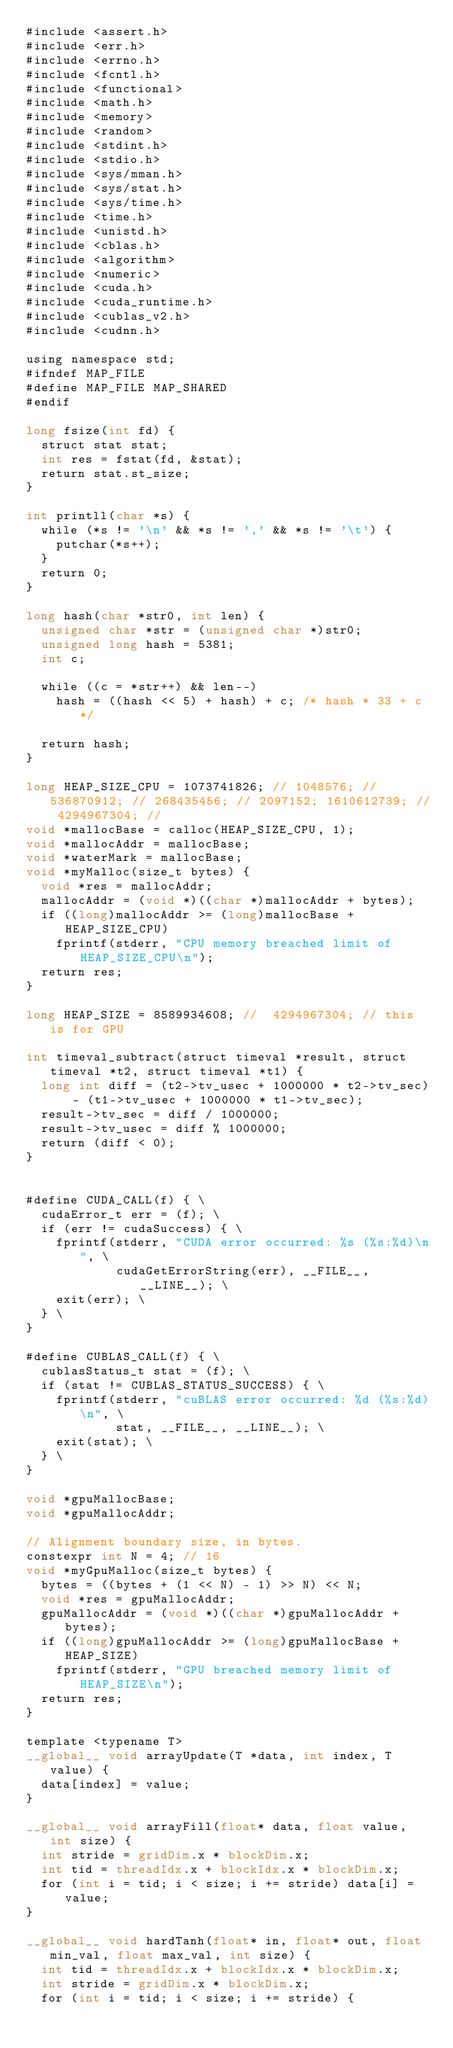Convert code to text. <code><loc_0><loc_0><loc_500><loc_500><_Cuda_>#include <assert.h>
#include <err.h>
#include <errno.h>
#include <fcntl.h>
#include <functional>
#include <math.h>
#include <memory>
#include <random>
#include <stdint.h>
#include <stdio.h>
#include <sys/mman.h>
#include <sys/stat.h>
#include <sys/time.h>
#include <time.h>
#include <unistd.h>
#include <cblas.h>
#include <algorithm>
#include <numeric>
#include <cuda.h>
#include <cuda_runtime.h>
#include <cublas_v2.h>
#include <cudnn.h>

using namespace std;
#ifndef MAP_FILE
#define MAP_FILE MAP_SHARED
#endif

long fsize(int fd) {
  struct stat stat;
  int res = fstat(fd, &stat);
  return stat.st_size;
}

int printll(char *s) {
  while (*s != '\n' && *s != ',' && *s != '\t') {
    putchar(*s++);
  }
  return 0;
}

long hash(char *str0, int len) {
  unsigned char *str = (unsigned char *)str0;
  unsigned long hash = 5381;
  int c;

  while ((c = *str++) && len--)
    hash = ((hash << 5) + hash) + c; /* hash * 33 + c */

  return hash;
}

long HEAP_SIZE_CPU = 1073741826; // 1048576; // 536870912; // 268435456; // 2097152; 1610612739; // 4294967304; //
void *mallocBase = calloc(HEAP_SIZE_CPU, 1);
void *mallocAddr = mallocBase;
void *waterMark = mallocBase;
void *myMalloc(size_t bytes) {
  void *res = mallocAddr;
  mallocAddr = (void *)((char *)mallocAddr + bytes);
  if ((long)mallocAddr >= (long)mallocBase + HEAP_SIZE_CPU)
    fprintf(stderr, "CPU memory breached limit of HEAP_SIZE_CPU\n");
  return res;
}

long HEAP_SIZE = 8589934608; //  4294967304; // this is for GPU

int timeval_subtract(struct timeval *result, struct timeval *t2, struct timeval *t1) {
  long int diff = (t2->tv_usec + 1000000 * t2->tv_sec) - (t1->tv_usec + 1000000 * t1->tv_sec);
  result->tv_sec = diff / 1000000;
  result->tv_usec = diff % 1000000;
  return (diff < 0);
}


#define CUDA_CALL(f) { \
  cudaError_t err = (f); \
  if (err != cudaSuccess) { \
    fprintf(stderr, "CUDA error occurred: %s (%s:%d)\n", \
            cudaGetErrorString(err), __FILE__, __LINE__); \
    exit(err); \
  } \
}

#define CUBLAS_CALL(f) { \
  cublasStatus_t stat = (f); \
  if (stat != CUBLAS_STATUS_SUCCESS) { \
    fprintf(stderr, "cuBLAS error occurred: %d (%s:%d)\n", \
            stat, __FILE__, __LINE__); \
    exit(stat); \
  } \
}

void *gpuMallocBase;
void *gpuMallocAddr;

// Alignment boundary size, in bytes.
constexpr int N = 4; // 16
void *myGpuMalloc(size_t bytes) {
  bytes = ((bytes + (1 << N) - 1) >> N) << N;
  void *res = gpuMallocAddr;
  gpuMallocAddr = (void *)((char *)gpuMallocAddr + bytes);
  if ((long)gpuMallocAddr >= (long)gpuMallocBase + HEAP_SIZE)
    fprintf(stderr, "GPU breached memory limit of HEAP_SIZE\n");
  return res;
}

template <typename T>
__global__ void arrayUpdate(T *data, int index, T value) {
  data[index] = value;
}

__global__ void arrayFill(float* data, float value, int size) {
  int stride = gridDim.x * blockDim.x;
  int tid = threadIdx.x + blockIdx.x * blockDim.x;
  for (int i = tid; i < size; i += stride) data[i] = value;
}

__global__ void hardTanh(float* in, float* out, float min_val, float max_val, int size) {
  int tid = threadIdx.x + blockIdx.x * blockDim.x;
  int stride = gridDim.x * blockDim.x;
  for (int i = tid; i < size; i += stride) {</code> 